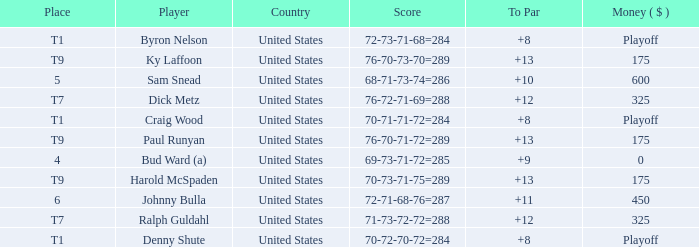What was craig wood's overall to par score? 8.0. Could you parse the entire table as a dict? {'header': ['Place', 'Player', 'Country', 'Score', 'To Par', 'Money ( $ )'], 'rows': [['T1', 'Byron Nelson', 'United States', '72-73-71-68=284', '+8', 'Playoff'], ['T9', 'Ky Laffoon', 'United States', '76-70-73-70=289', '+13', '175'], ['5', 'Sam Snead', 'United States', '68-71-73-74=286', '+10', '600'], ['T7', 'Dick Metz', 'United States', '76-72-71-69=288', '+12', '325'], ['T1', 'Craig Wood', 'United States', '70-71-71-72=284', '+8', 'Playoff'], ['T9', 'Paul Runyan', 'United States', '76-70-71-72=289', '+13', '175'], ['4', 'Bud Ward (a)', 'United States', '69-73-71-72=285', '+9', '0'], ['T9', 'Harold McSpaden', 'United States', '70-73-71-75=289', '+13', '175'], ['6', 'Johnny Bulla', 'United States', '72-71-68-76=287', '+11', '450'], ['T7', 'Ralph Guldahl', 'United States', '71-73-72-72=288', '+12', '325'], ['T1', 'Denny Shute', 'United States', '70-72-70-72=284', '+8', 'Playoff']]} 